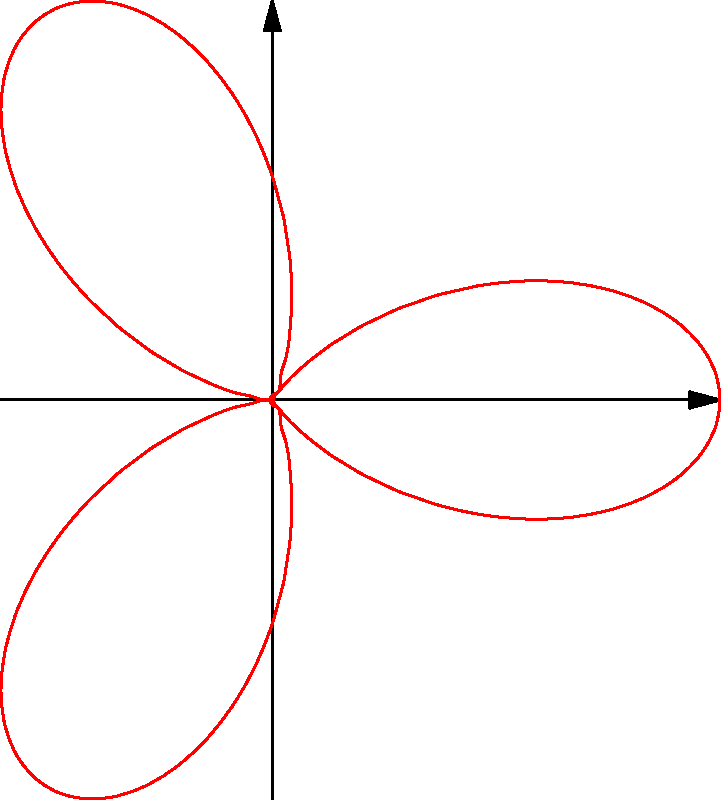As a Grade 1 teacher, you want to introduce your students to simple shapes using polar coordinates. Which equation would you use to create a simple flower shape with three petals, as shown in the graph above?

a) $r = 1 + \cos(2\theta)$
b) $r = 1 + \cos(3\theta)$
c) $r = 1 + \sin(3\theta)$
d) $r = 1 + \sin(2\theta)$ Let's break this down step-by-step:

1) The graph shows a flower-like shape with three distinct petals.

2) In polar coordinates, the general equation for creating petal-like shapes is $r = 1 + \cos(n\theta)$ or $r = 1 + \sin(n\theta)$, where $n$ determines the number of petals.

3) To get three petals, we need $n = 3$.

4) Looking at the shape, we can see that the petals are aligned with the x-axis, which is characteristic of a cosine function rather than a sine function.

5) Therefore, the equation we're looking for should be in the form $r = 1 + \cos(3\theta)$.

6) This matches option b) in the question.

As a Grade 1 teacher, you could simplify this for your students by describing it as "a circle that gets bigger and smaller three times as you go around it," which creates the flower shape.
Answer: b) $r = 1 + \cos(3\theta)$ 